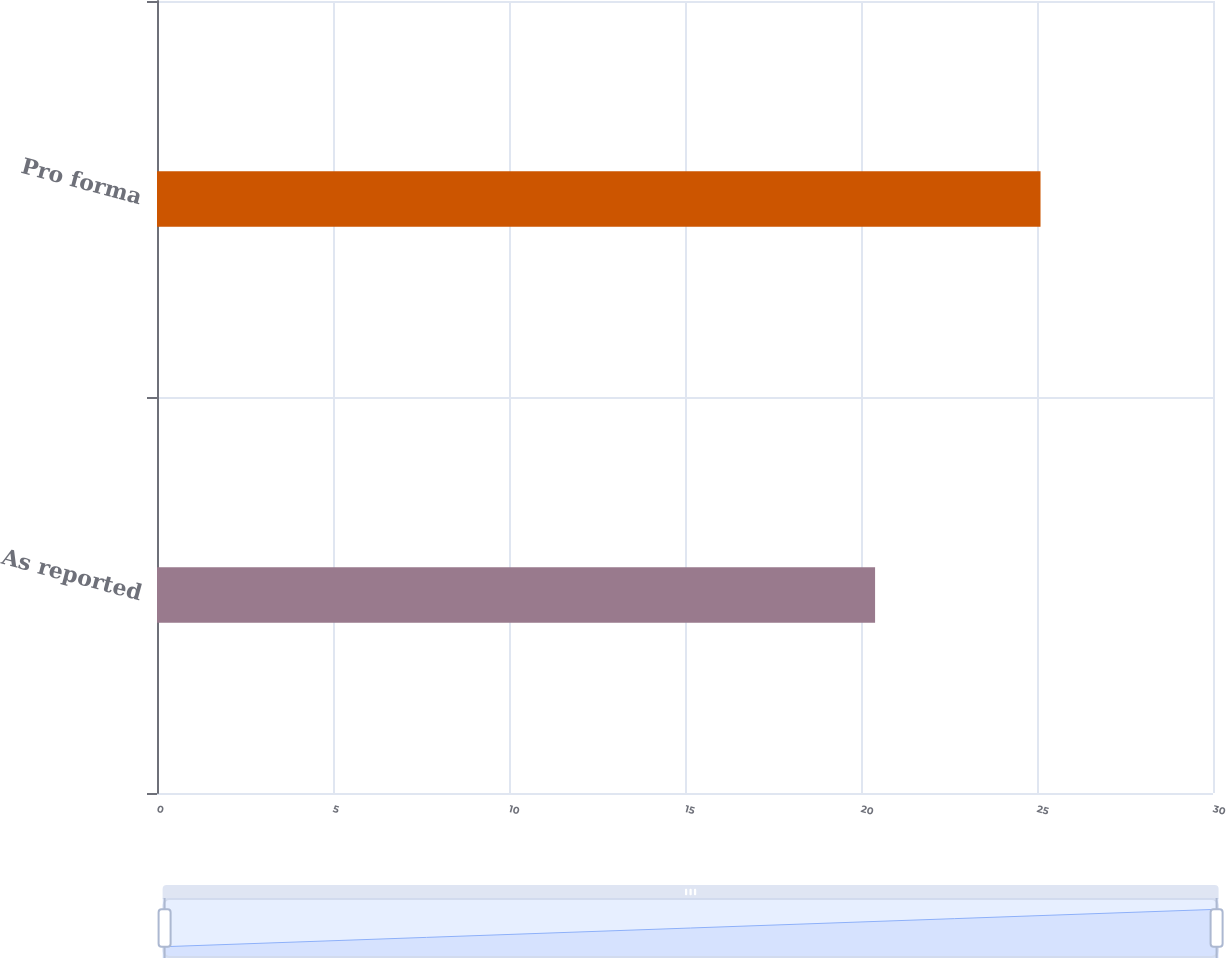Convert chart. <chart><loc_0><loc_0><loc_500><loc_500><bar_chart><fcel>As reported<fcel>Pro forma<nl><fcel>20.4<fcel>25.1<nl></chart> 